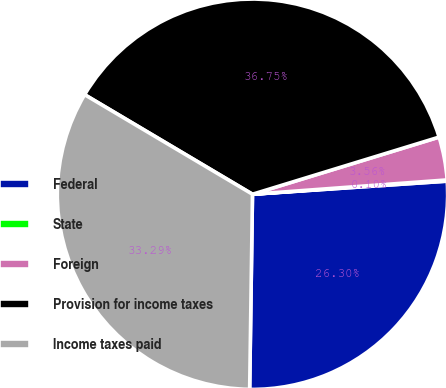Convert chart to OTSL. <chart><loc_0><loc_0><loc_500><loc_500><pie_chart><fcel>Federal<fcel>State<fcel>Foreign<fcel>Provision for income taxes<fcel>Income taxes paid<nl><fcel>26.3%<fcel>0.1%<fcel>3.56%<fcel>36.75%<fcel>33.29%<nl></chart> 